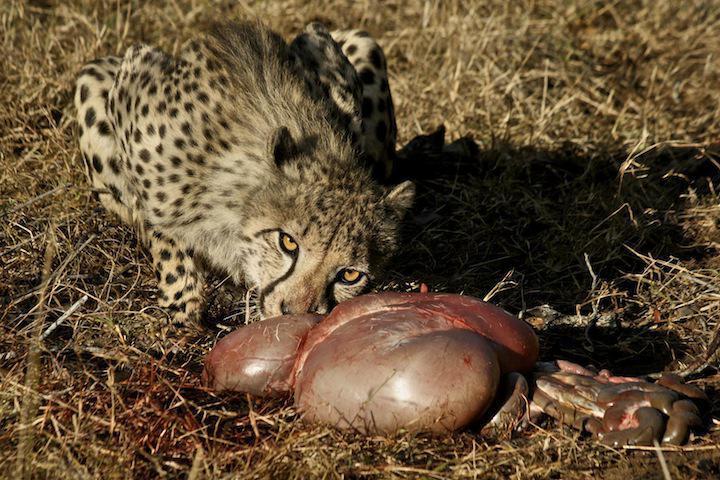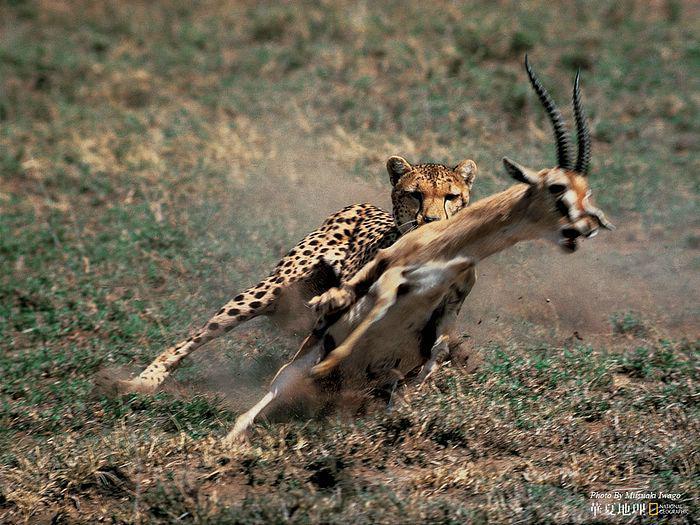The first image is the image on the left, the second image is the image on the right. Evaluate the accuracy of this statement regarding the images: "The right image shows one cheetah capturing a gazelle-type animal, and the left image shows a cheetah crouched behind entrails.". Is it true? Answer yes or no. Yes. 